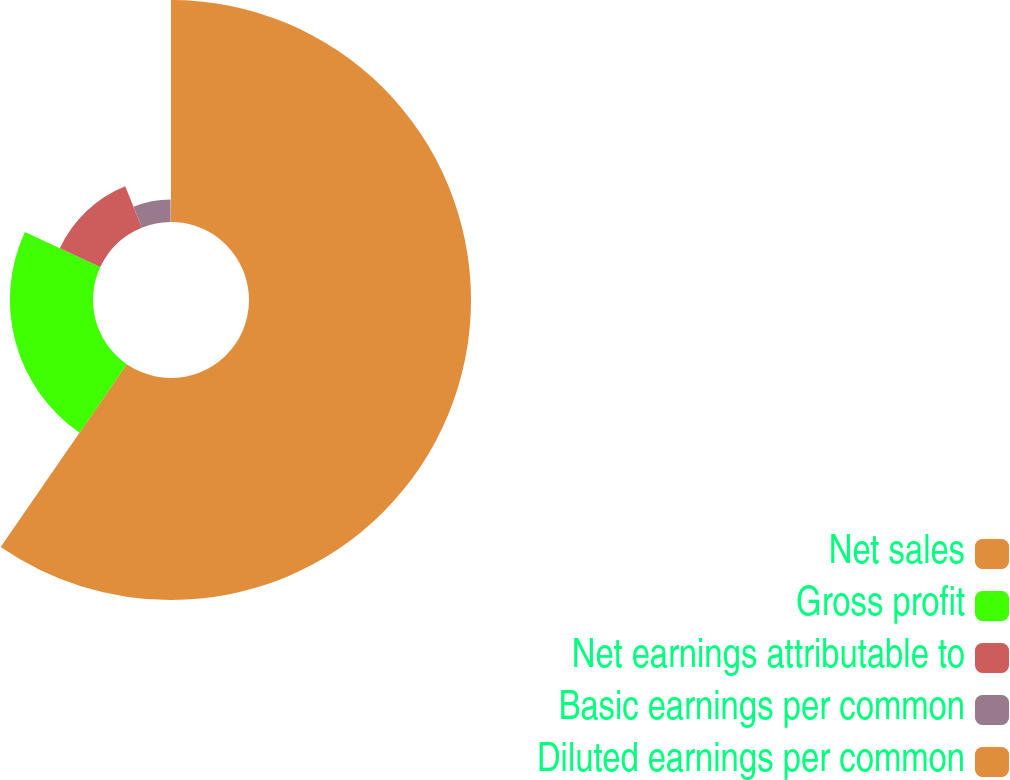Convert chart to OTSL. <chart><loc_0><loc_0><loc_500><loc_500><pie_chart><fcel>Net sales<fcel>Gross profit<fcel>Net earnings attributable to<fcel>Basic earnings per common<fcel>Diluted earnings per common<nl><fcel>59.61%<fcel>22.32%<fcel>11.98%<fcel>6.02%<fcel>0.07%<nl></chart> 